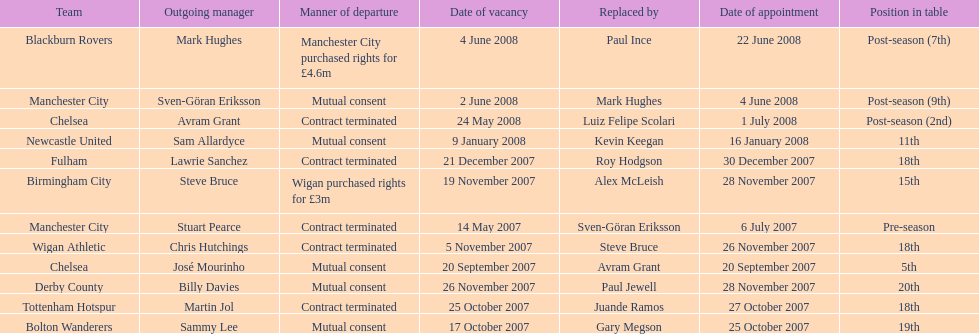How many teams had a manner of departure due to there contract being terminated? 5. 